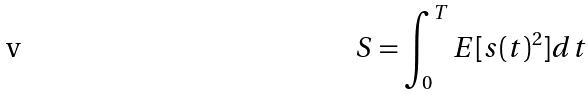<formula> <loc_0><loc_0><loc_500><loc_500>S = \int _ { 0 } ^ { T } E [ s ( t ) ^ { 2 } ] d t</formula> 